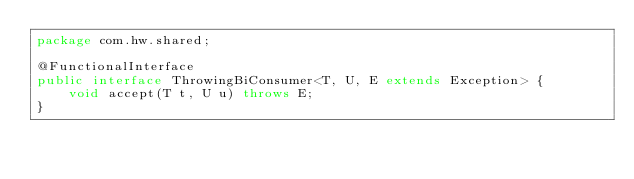<code> <loc_0><loc_0><loc_500><loc_500><_Java_>package com.hw.shared;

@FunctionalInterface
public interface ThrowingBiConsumer<T, U, E extends Exception> {
    void accept(T t, U u) throws E;
}
</code> 